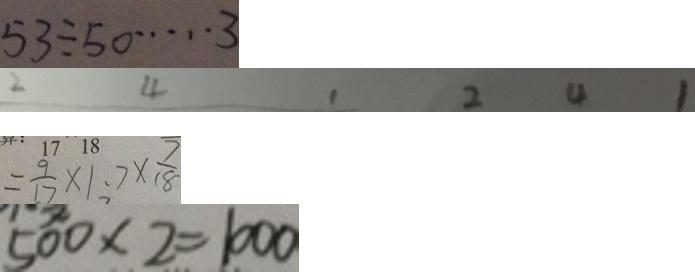<formula> <loc_0><loc_0><loc_500><loc_500>5 3 \div 5 0 \cdots 3 
 2 4 1 2 4 1 
 = \frac { 9 } { 1 7 } \times 1 . 7 \times \frac { 7 } { 1 8 } 
 5 0 0 \times 2 = 1 0 0 0</formula> 